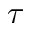Convert formula to latex. <formula><loc_0><loc_0><loc_500><loc_500>\tau</formula> 